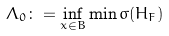Convert formula to latex. <formula><loc_0><loc_0><loc_500><loc_500>\Lambda _ { 0 } \colon = \inf _ { x \in B } \min \sigma ( H _ { F } )</formula> 